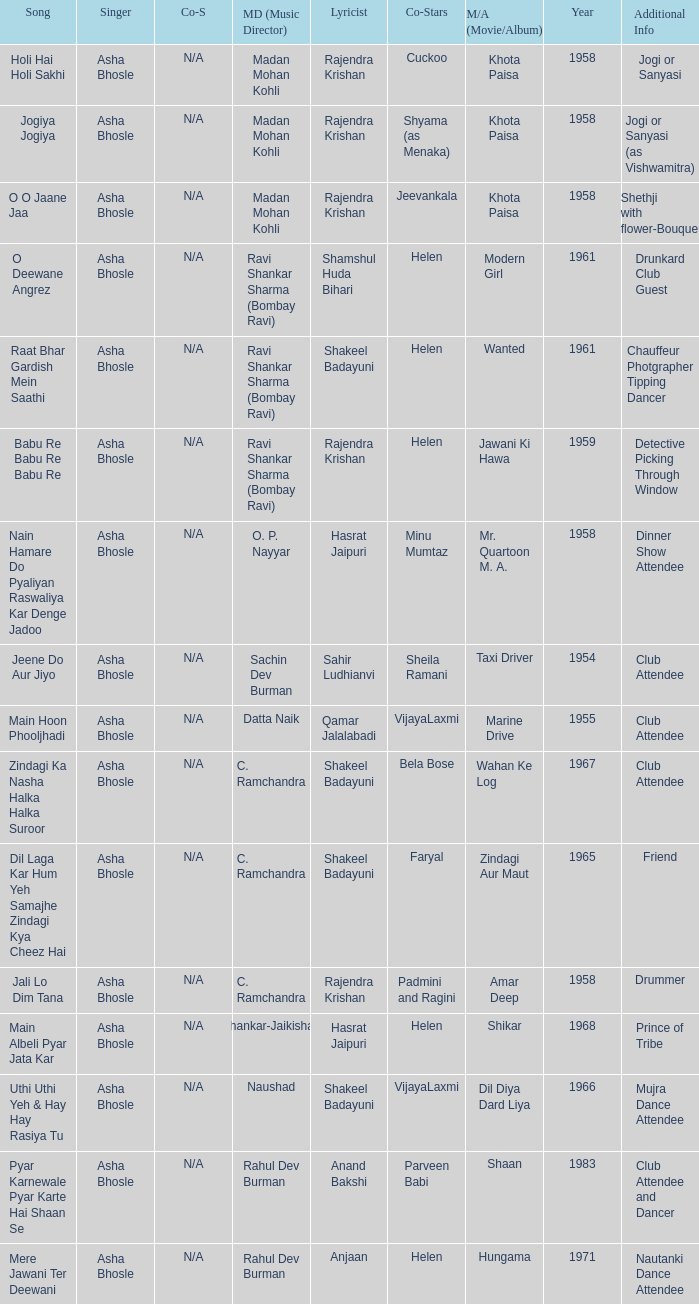What movie did Vijayalaxmi Co-star in and Shakeel Badayuni write the lyrics? Dil Diya Dard Liya. 